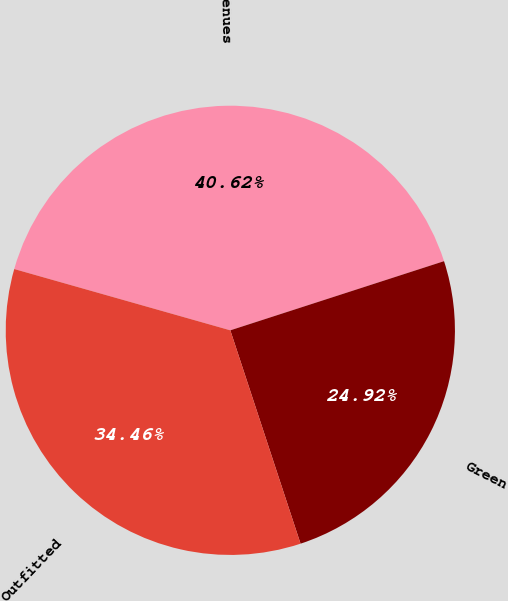<chart> <loc_0><loc_0><loc_500><loc_500><pie_chart><fcel>Revenues<fcel>Green<fcel>Outfitted<nl><fcel>40.62%<fcel>24.92%<fcel>34.46%<nl></chart> 